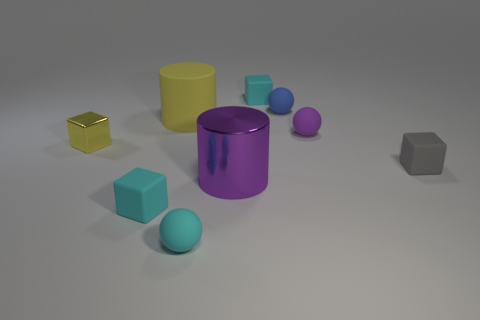Do the shiny cube and the rubber cylinder have the same color?
Make the answer very short. Yes. How many large yellow rubber things are the same shape as the small blue thing?
Your answer should be compact. 0. What is the shape of the tiny purple thing that is the same material as the blue object?
Your response must be concise. Sphere. How many blue things are either small blocks or tiny rubber blocks?
Ensure brevity in your answer.  0. There is a big purple thing; are there any metallic cubes behind it?
Your response must be concise. Yes. There is a cyan object that is behind the purple metallic object; is its shape the same as the purple thing that is behind the tiny metallic block?
Your answer should be compact. No. There is another large thing that is the same shape as the large purple metal object; what is it made of?
Your answer should be compact. Rubber. What number of balls are either purple rubber objects or blue objects?
Your answer should be very brief. 2. How many large things are the same material as the small gray thing?
Provide a succinct answer. 1. Do the big yellow cylinder that is to the left of the large purple metallic cylinder and the small sphere behind the small purple rubber sphere have the same material?
Make the answer very short. Yes. 